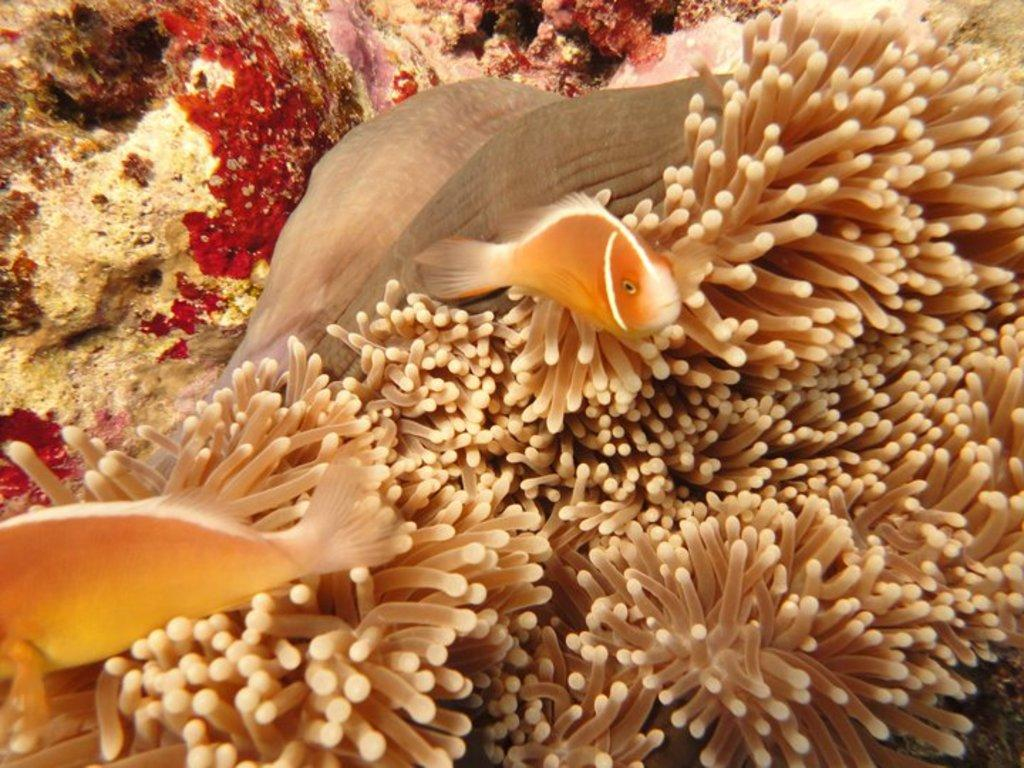How many fishes can be seen in the image? There are two fishes in the image. What color are the fishes? The fishes are orange in color. What other marine life can be seen in the image? There are clusters of sea anemones at the bottom of the image. Where might this image have been taken? The image might have been taken in an aquarium. What type of wheel can be seen attached to the fishes in the image? There is no wheel present in the image; it features two orange fishes and sea anemones. Where is the mailbox located in the image? There is no mailbox present in the image; it is a marine life scene with fishes and sea anemones. 